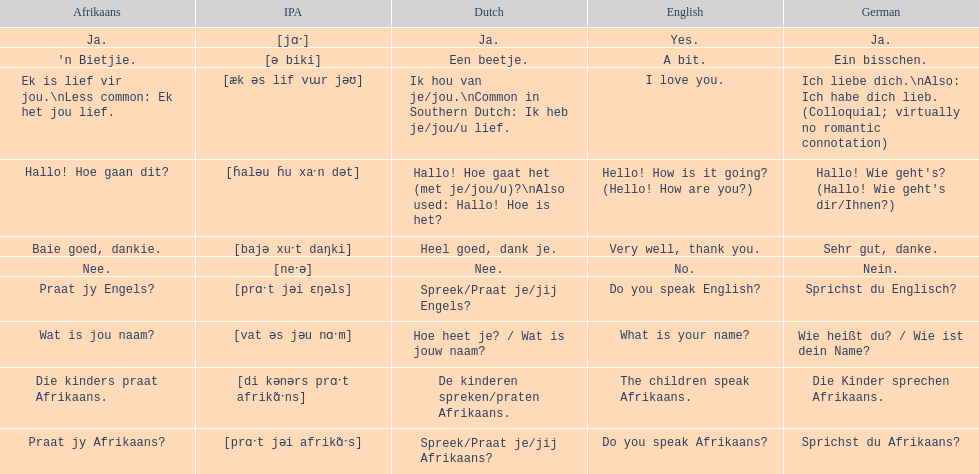How do you say "do you speak afrikaans?" in afrikaans? Praat jy Afrikaans?. 